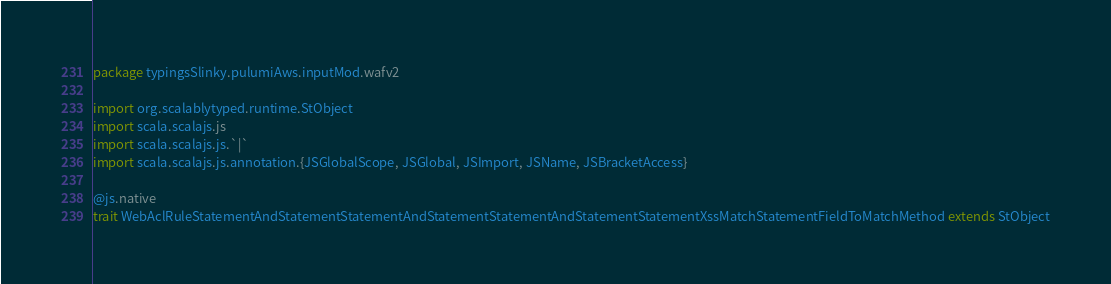<code> <loc_0><loc_0><loc_500><loc_500><_Scala_>package typingsSlinky.pulumiAws.inputMod.wafv2

import org.scalablytyped.runtime.StObject
import scala.scalajs.js
import scala.scalajs.js.`|`
import scala.scalajs.js.annotation.{JSGlobalScope, JSGlobal, JSImport, JSName, JSBracketAccess}

@js.native
trait WebAclRuleStatementAndStatementStatementAndStatementStatementAndStatementStatementXssMatchStatementFieldToMatchMethod extends StObject
</code> 